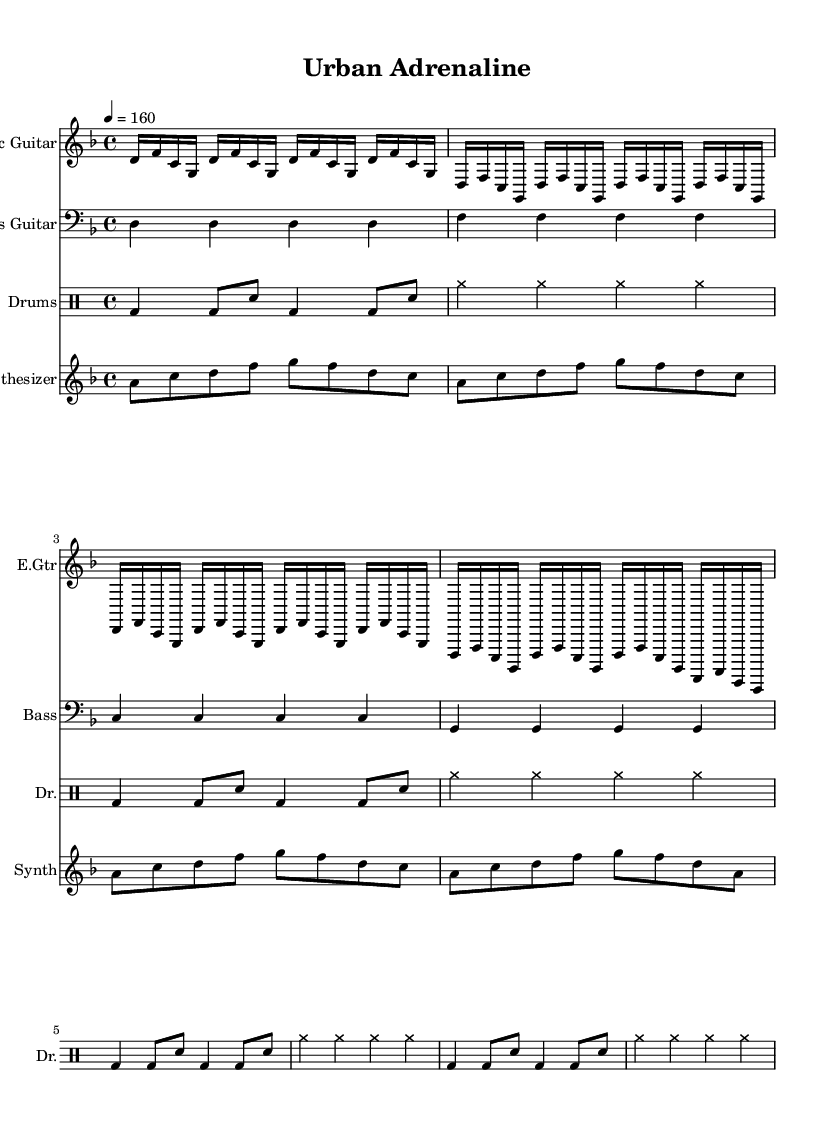What is the key signature of this music? The key signature is indicated at the beginning of the score, showing two flats which corresponds to the key of D minor.
Answer: D minor What is the time signature of this music? The time signature is placed at the beginning of the score and indicates that there are four beats per measure. This is shown as 4/4.
Answer: 4/4 What is the tempo marking of this music? The tempo marking indicates the speed of the piece, which is set to 160 beats per minute, as noted in the score.
Answer: 160 How many measures are in the electric guitar part? By counting the repeated sections in the electric guitar part, we find that there are a total of 16 measures, split into groups of 4, 4, 4, and 3, plus additional notes.
Answer: 16 What type of drums are used in this score? The drum part uses standard notations and includes elements like bass drum, snare, and cymbals, making it fit within the industrial metal genre.
Answer: Bass drum, snare, cymbals What is the highest note played by the synthesizer? The synthesizer part shows the highest pitch, which is an A in the last measure, making it the peak of the melodic line.
Answer: A Which instrument plays a consistent pattern throughout? The bass guitar consistently plays the same note, D, for each measure, establishing a solid rhythmic foundation essential in metal music.
Answer: Bass guitar 